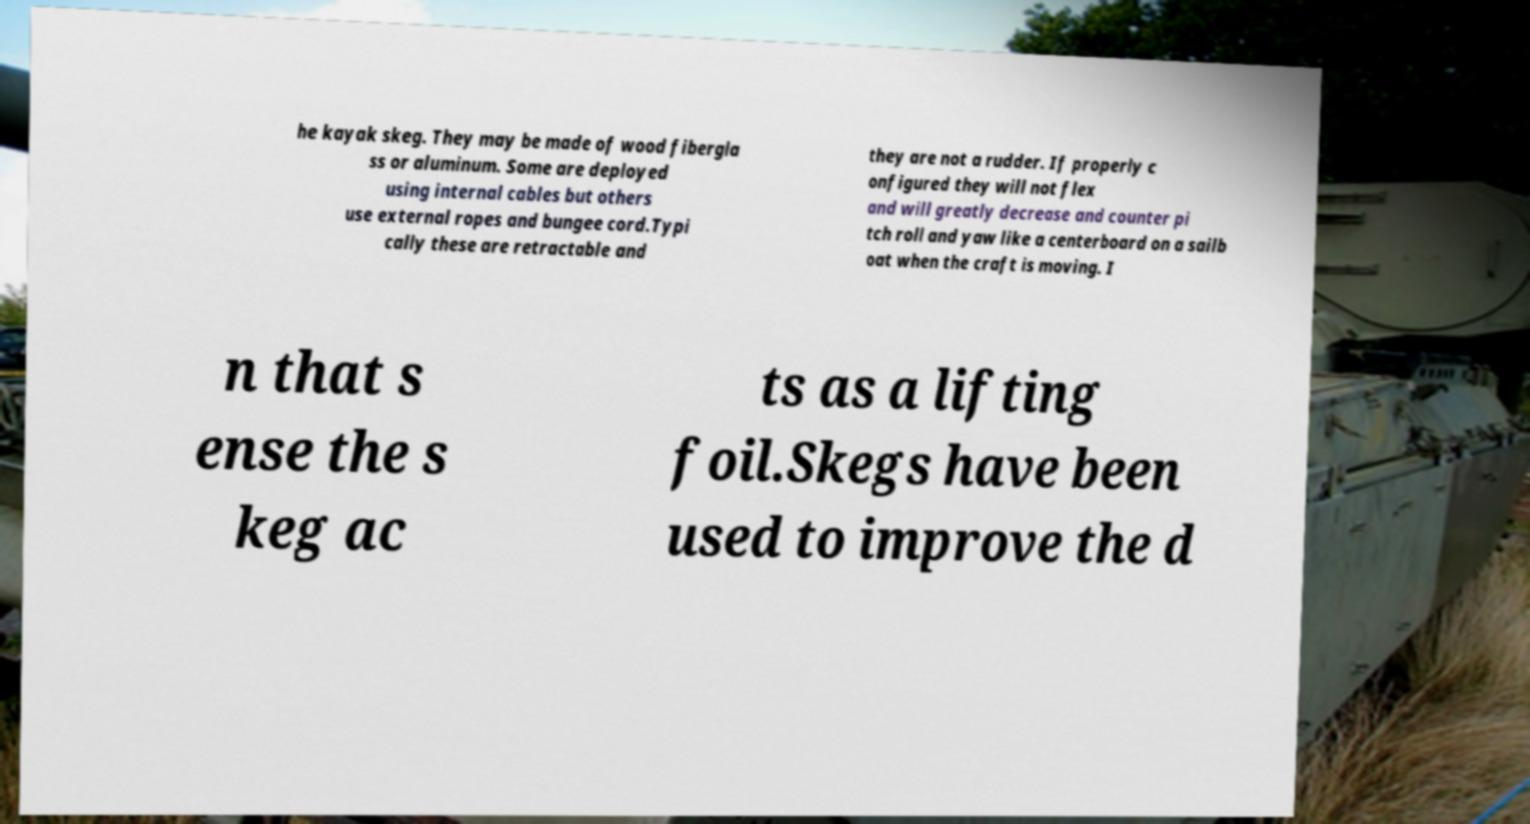For documentation purposes, I need the text within this image transcribed. Could you provide that? he kayak skeg. They may be made of wood fibergla ss or aluminum. Some are deployed using internal cables but others use external ropes and bungee cord.Typi cally these are retractable and they are not a rudder. If properly c onfigured they will not flex and will greatly decrease and counter pi tch roll and yaw like a centerboard on a sailb oat when the craft is moving. I n that s ense the s keg ac ts as a lifting foil.Skegs have been used to improve the d 